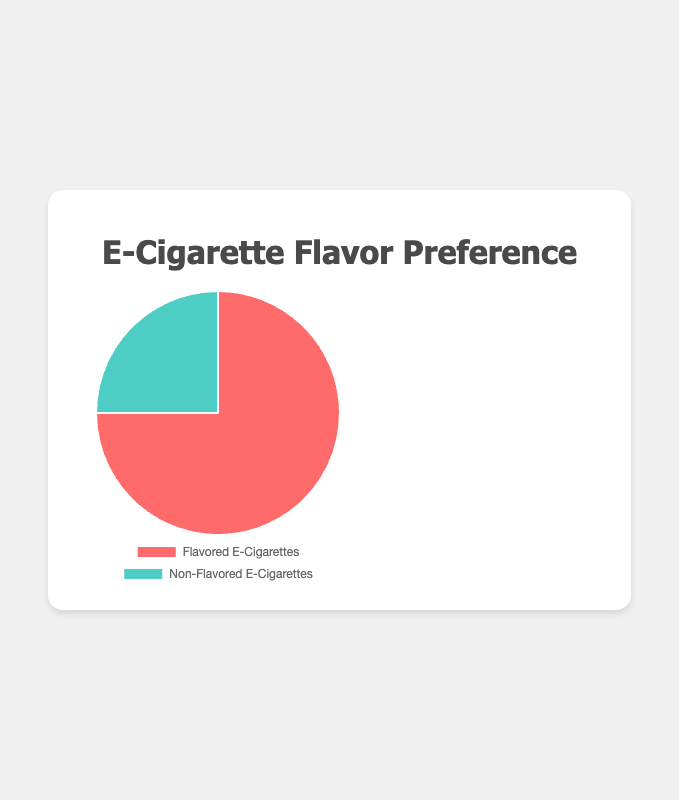Which category of e-cigarette products do consumers prefer more? From the pie chart, we can see that the 'Flavored E-Cigarettes' section is larger than the 'Non-Flavored E-Cigarettes' section. This indicates that consumers prefer flavored e-cigarettes more.
Answer: Flavored E-Cigarettes What percentage of consumers prefer flavored e-cigarettes over non-flavored ones? The pie chart shows the preference ratio for 'Flavored E-Cigarettes' is 0.75, which corresponds to 75% of the total consumer preferences.
Answer: 75% How much more do consumers prefer flavored e-cigarettes compared to non-flavored e-cigarettes? The preference ratio for 'Flavored E-Cigarettes' is 0.75, and for 'Non-Flavored E-Cigarettes' is 0.25. The difference is 0.75 - 0.25, which equals 0.50 or 50%.
Answer: 50% Is the preference for non-flavored e-cigarettes less than half of the total consumer preferences? The pie chart shows that the preference ratio for 'Non-Flavored E-Cigarettes' is 0.25, which is less than half of the total (0.50) consumer preferences.
Answer: Yes If the chart were divided into 100 equal parts, how many parts would each category occupy? 'Flavored E-Cigarettes' would occupy 75 parts (0.75 * 100) and 'Non-Flavored E-Cigarettes' would occupy 25 parts (0.25 * 100).
Answer: Flavored: 75 parts, Non-Flavored: 25 parts What's the combined percentage of flavored and non-flavored e-cigarettes according to consumer preferences? The combined percentage is the sum of the percentages for 'Flavored E-Cigarettes' and 'Non-Flavored E-Cigarettes', which is 75% + 25% = 100%.
Answer: 100% Which section has a more vibrant color in the pie chart? The 'Flavored E-Cigarettes' section is depicted in red, which is a more vibrant color compared to the green used for 'Non-Flavored E-Cigarettes'.
Answer: Flavored E-Cigarettes What is the visual representation for non-flavored e-cigarettes in the chart? The 'Non-Flavored E-Cigarettes' section is represented in green on the pie chart.
Answer: Green 